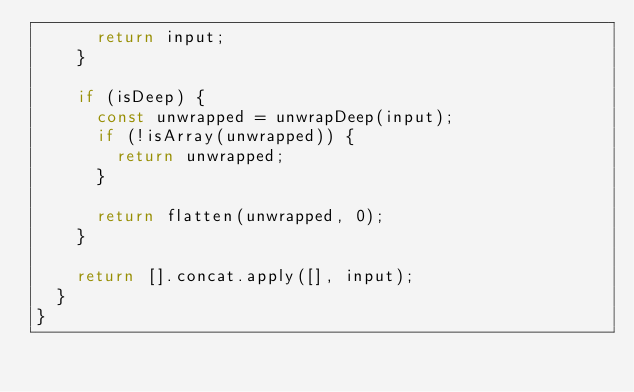Convert code to text. <code><loc_0><loc_0><loc_500><loc_500><_TypeScript_>      return input;
    }
    
    if (isDeep) {
      const unwrapped = unwrapDeep(input);
      if (!isArray(unwrapped)) {
        return unwrapped;
      }
      
      return flatten(unwrapped, 0);
    }
    
    return [].concat.apply([], input);
  }
}</code> 